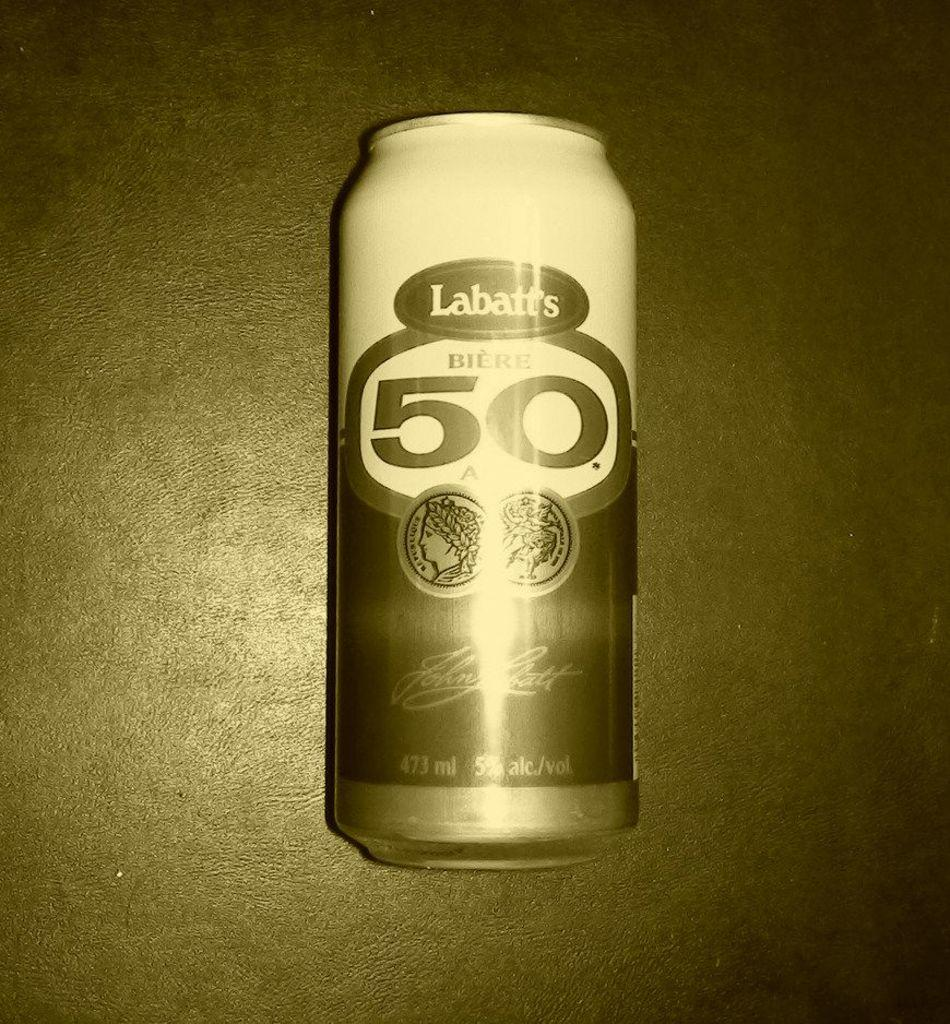<image>
Give a short and clear explanation of the subsequent image. a can of Labatts 50 beer with a tin filter on it. 